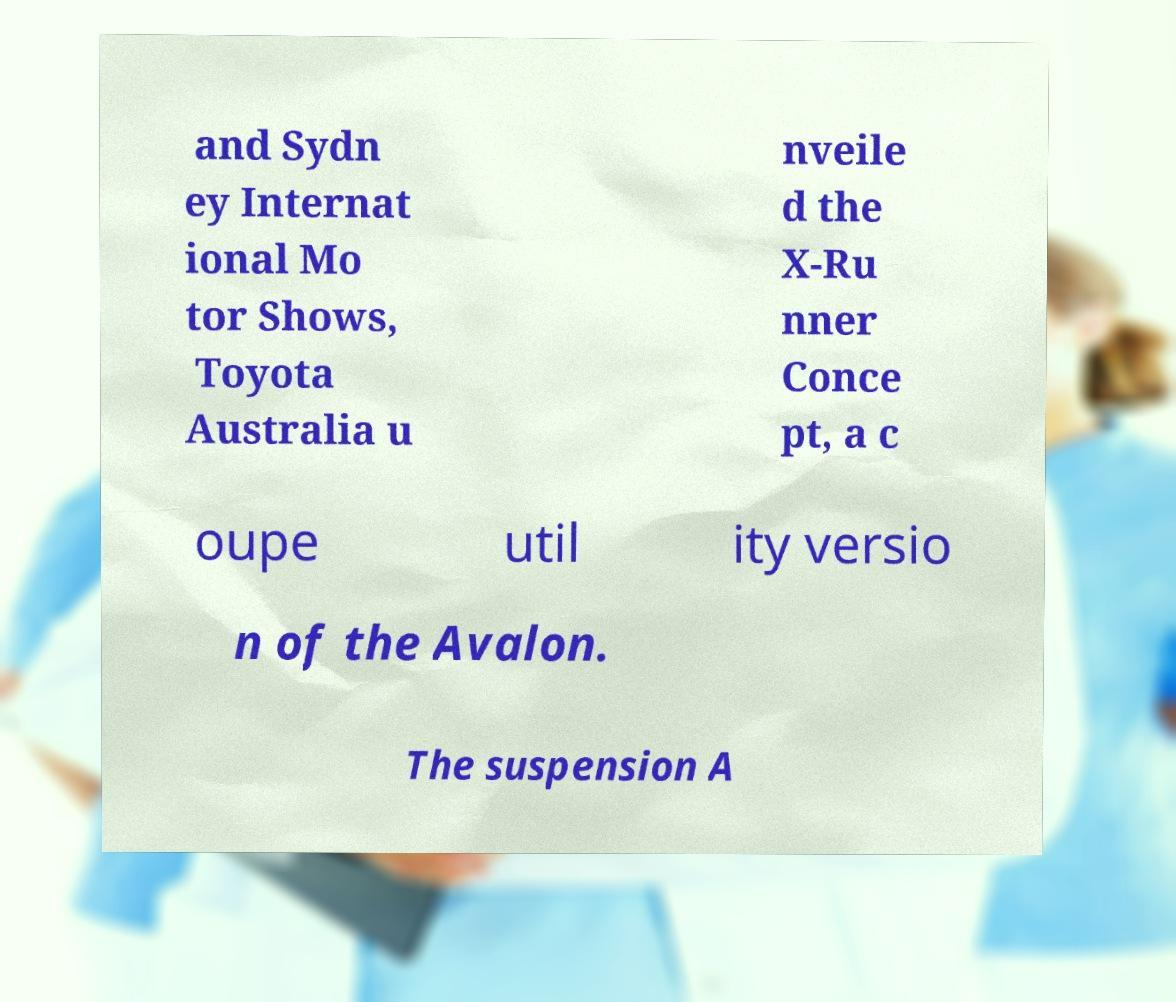Could you extract and type out the text from this image? and Sydn ey Internat ional Mo tor Shows, Toyota Australia u nveile d the X-Ru nner Conce pt, a c oupe util ity versio n of the Avalon. The suspension A 